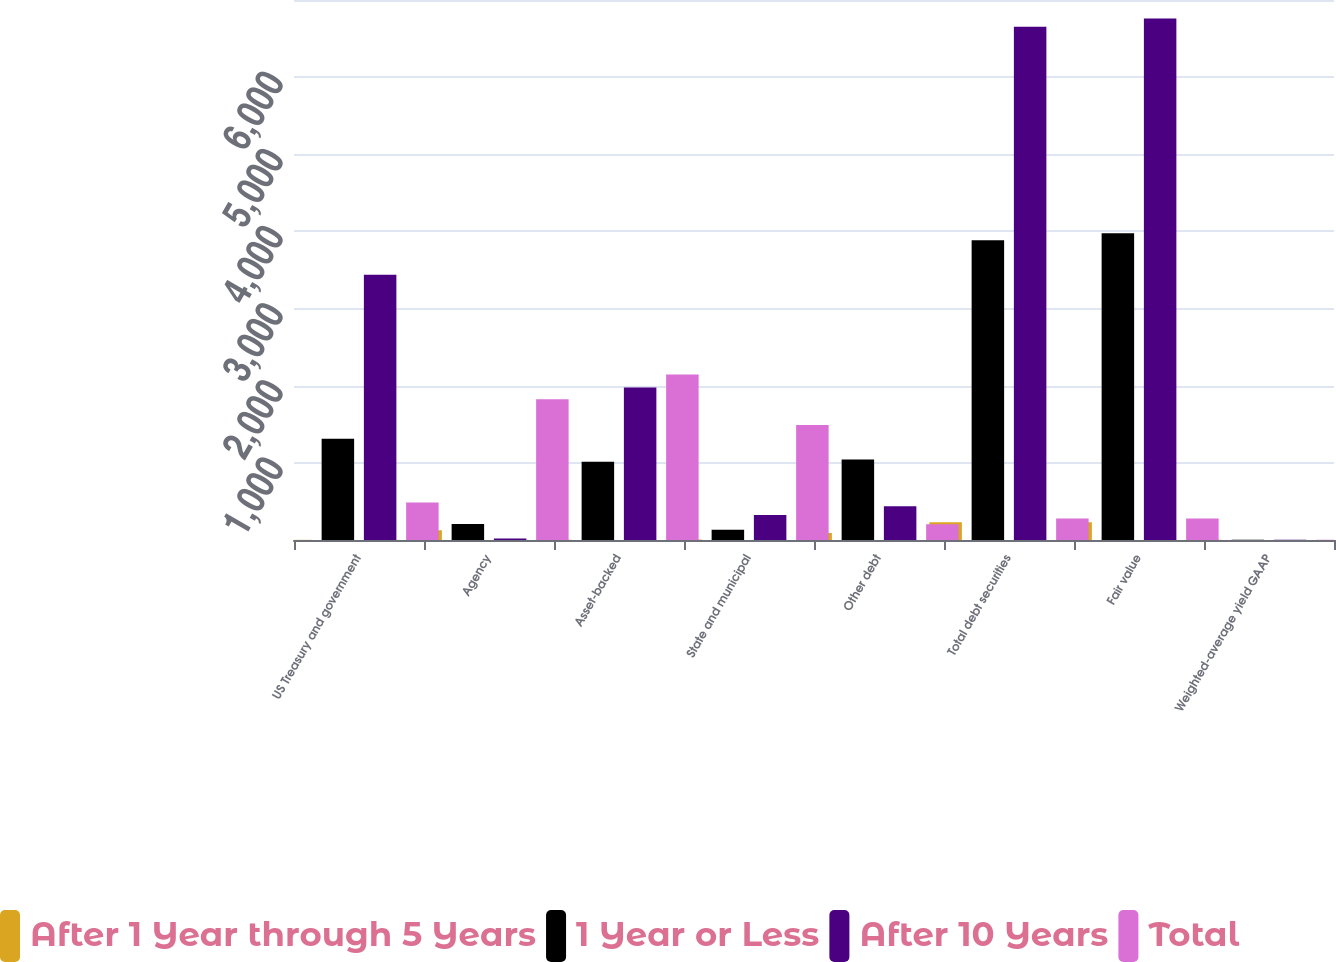Convert chart to OTSL. <chart><loc_0><loc_0><loc_500><loc_500><stacked_bar_chart><ecel><fcel>US Treasury and government<fcel>Agency<fcel>Asset-backed<fcel>State and municipal<fcel>Other debt<fcel>Total debt securities<fcel>Fair value<fcel>Weighted-average yield GAAP<nl><fcel>After 1 Year through 5 Years<fcel>2<fcel>128<fcel>4<fcel>5<fcel>91<fcel>230<fcel>231<fcel>3.49<nl><fcel>1 Year or Less<fcel>1312<fcel>206<fcel>1014<fcel>134<fcel>1045<fcel>3887<fcel>3976<fcel>2.55<nl><fcel>After 10 Years<fcel>3437<fcel>20<fcel>1977<fcel>324<fcel>437<fcel>6652<fcel>6760<fcel>2.36<nl><fcel>Total<fcel>486<fcel>1824<fcel>2146<fcel>1490<fcel>203<fcel>277.5<fcel>277.5<fcel>2.99<nl></chart> 